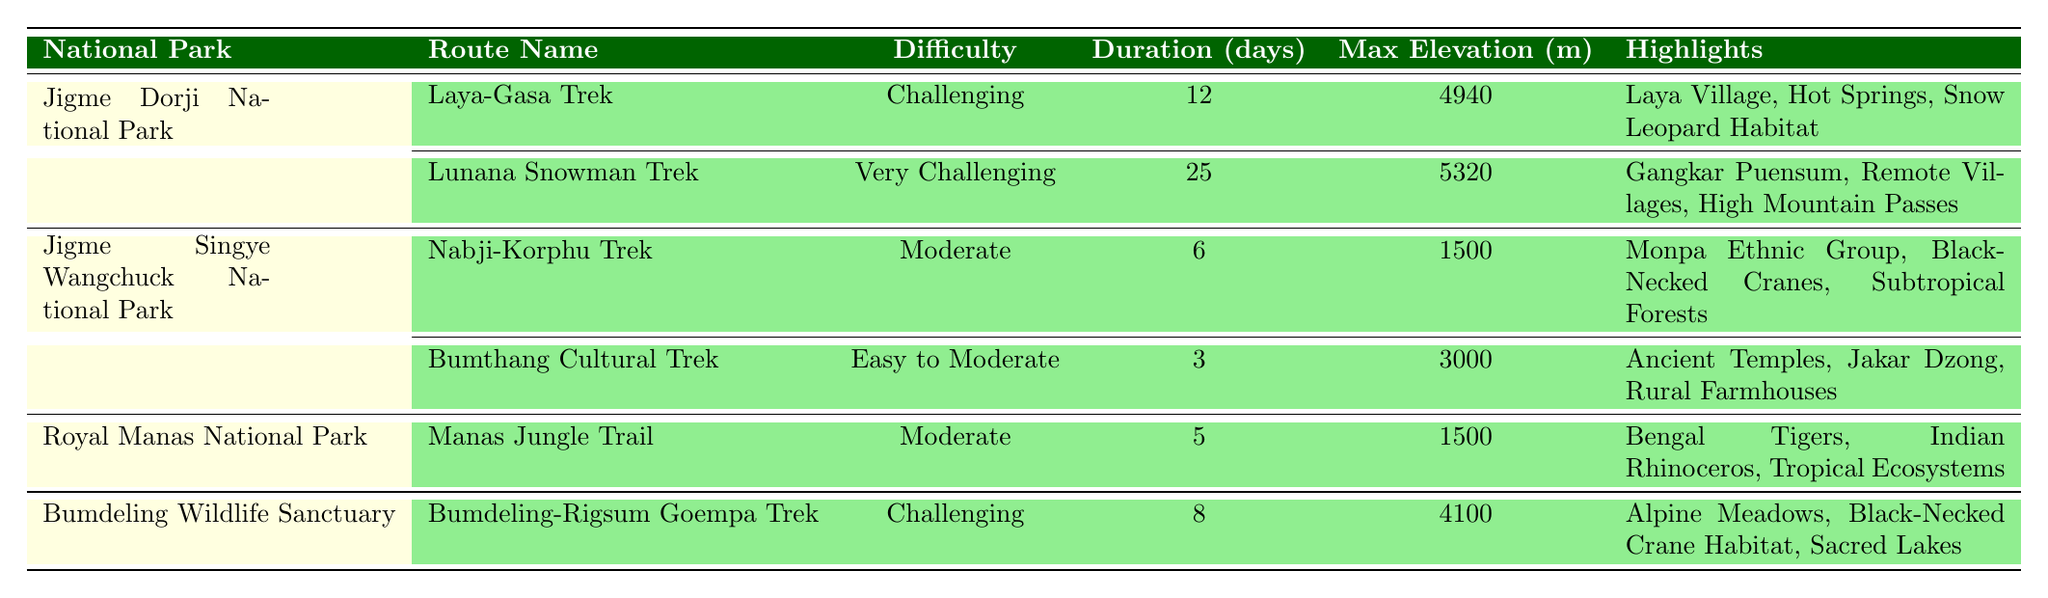What is the maximum elevation of the Laya-Gasa Trek? The table lists the maximum elevation for the Laya-Gasa Trek under the "Max Elevation (m)" column, which is 4940 meters.
Answer: 4940 m How many days does the Lunana Snowman Trek last? The duration of the Lunana Snowman Trek is found in the "Duration (days)" column, which states that it lasts for 25 days.
Answer: 25 days Which trek has the most challenging rating? By examining the "Difficulty" column, the Lunana Snowman Trek is labeled as "Very Challenging," which is the highest rating among all listed treks.
Answer: Lunana Snowman Trek Is the Nabji-Korphu Trek considered easy? The difficulty rating for the Nabji-Korphu Trek is "Moderate," which means it is not classified as easy, making the statement false.
Answer: No Which national park has the most routes listed? The table contains two routes for Jigme Dorji National Park, two for Jigme Singye Wangchuck National Park, one for Royal Manas National Park, and one for Bumdeling Wildlife Sanctuary. Neither park has more routes than Jigme Dorji National Park. Thus, the answer is Jigme Dorji National Park.
Answer: Jigme Dorji National Park How does the maximum elevation of the Bumdeling-Rigsum Goempa Trek compare with the Laya-Gasa Trek? The max elevation of the Bumdeling-Rigsum Goempa Trek is 4100 m, which is 840 m lower than the Laya-Gasa Trek's 4940 m elevation.
Answer: 840 m lower What is the average duration of the treks listed in Jigme Singye Wangchuck National Park? The two treks in this park last for 6 days and 3 days, respectively. Their average is (6 + 3) / 2 = 4.5 days.
Answer: 4.5 days Which park features treks that highlight the Black-Necked Crane? Both the Nabji-Korphu Trek and the Bumdeling-Rigsum Goempa Trek within Jigme Singye Wangchuck National Park and Bumdeling Wildlife Sanctuary mention Black-Necked Cranes in their highlights, confirming their presence in these parks.
Answer: Jigme Singye Wangchuck National Park and Bumdeling Wildlife Sanctuary Is there a trek lasting fewer than 5 days listed in the table? The Bumthang Cultural Trek lasts only 3 days, which is less than 5 days, making the statement true.
Answer: Yes Which trek has the highest maximum elevation and what is that elevation? The Lunana Snowman Trek has the highest maximum elevation listed, which is 5320 m.
Answer: 5320 m 